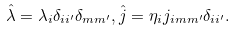<formula> <loc_0><loc_0><loc_500><loc_500>\hat { \lambda } = \lambda _ { i } \delta _ { i i ^ { \prime } } \delta _ { m m ^ { \prime } } , \hat { j } = \eta _ { i } j _ { i m m ^ { \prime } } \delta _ { i i ^ { \prime } } .</formula> 